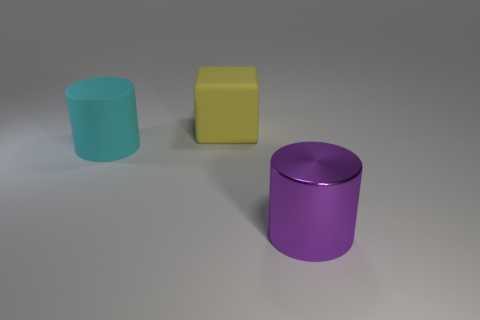How many other objects are there of the same shape as the large purple thing?
Make the answer very short. 1. What number of other cylinders have the same material as the purple cylinder?
Ensure brevity in your answer.  0. What shape is the yellow thing that is the same size as the purple cylinder?
Your response must be concise. Cube. There is a purple object; are there any large yellow rubber blocks on the right side of it?
Your answer should be compact. No. Are there any other large objects of the same shape as the purple thing?
Provide a succinct answer. Yes. Is the shape of the large thing that is in front of the cyan cylinder the same as the matte thing right of the matte cylinder?
Your answer should be compact. No. Is there another cube that has the same size as the yellow matte block?
Keep it short and to the point. No. Is the number of large rubber cylinders on the left side of the large cyan cylinder the same as the number of purple shiny cylinders behind the big yellow rubber cube?
Make the answer very short. Yes. Are the large thing that is left of the big yellow rubber block and the large object that is behind the cyan rubber cylinder made of the same material?
Your answer should be compact. Yes. What material is the big purple cylinder?
Your response must be concise. Metal. 